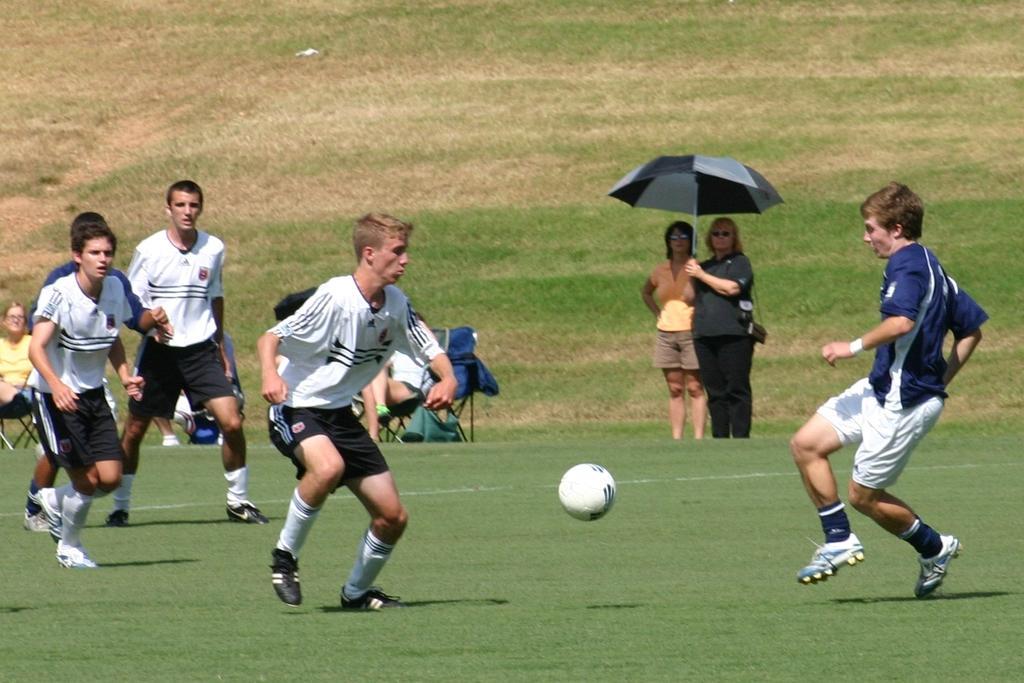In one or two sentences, can you explain what this image depicts? This picture is taken in a ground. There are four men towards the left and a one man towards the right. In middle of them there is a wall. Among them there are wearing white t shirts and two are wearing blue t shirts. Towards the right there are two in the center, one of them is holding an umbrella. In the background there is a hill with grass. 